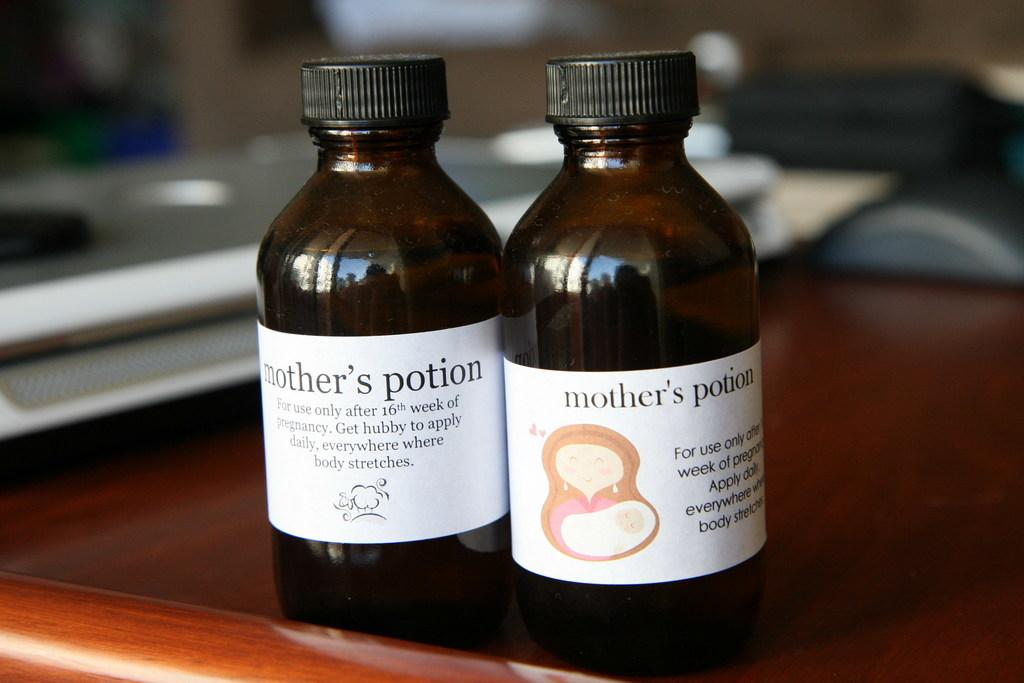Provide a one-sentence caption for the provided image. 2 bottles of medicine called mothers potion on the counter. 